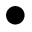<formula> <loc_0><loc_0><loc_500><loc_500>\bullet</formula> 